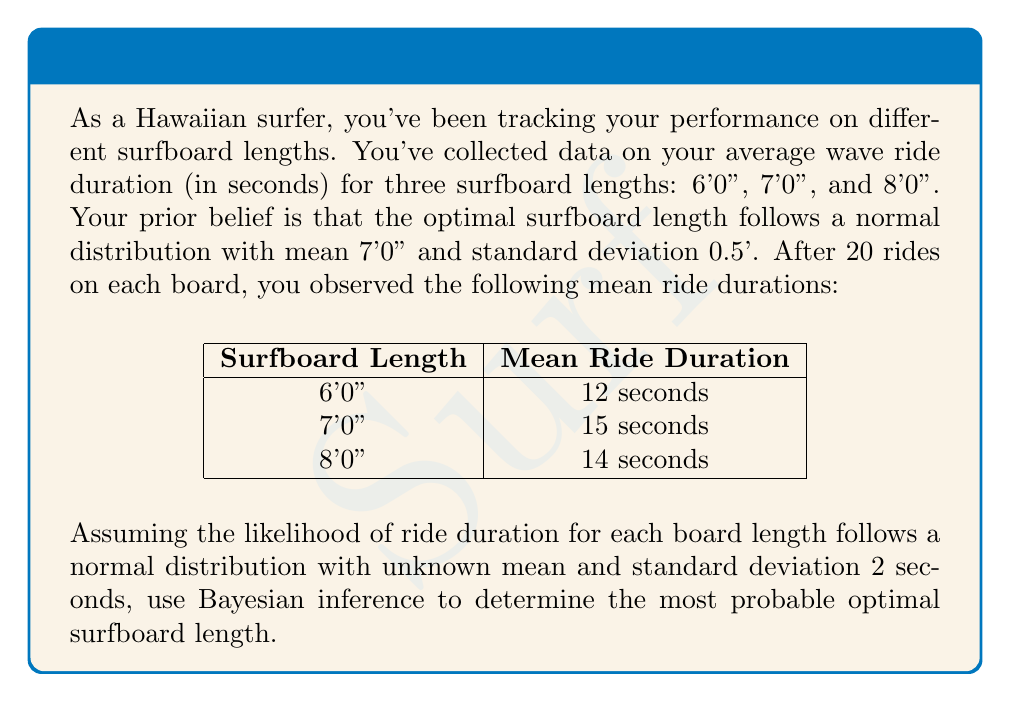Teach me how to tackle this problem. Let's approach this step-by-step using Bayesian inference:

1) Define our variables:
   $\theta$ = optimal surfboard length
   $D$ = observed data

2) We start with a prior distribution:
   $p(\theta) \sim N(7, 0.5^2)$

3) The likelihood function for each board length:
   $p(D|\theta) \sim N(\mu, 2^2)$
   where $\mu$ is the mean ride duration for each length

4) The posterior distribution is proportional to the prior times the likelihood:
   $p(\theta|D) \propto p(\theta) \cdot p(D|\theta)$

5) For each board length, we can calculate a likelihood:
   $L(6') \propto \exp(-\frac{(12-\theta)^2}{2\cdot2^2})$
   $L(7') \propto \exp(-\frac{(15-\theta)^2}{2\cdot2^2})$
   $L(8') \propto \exp(-\frac{(14-\theta)^2}{2\cdot2^2})$

6) The total likelihood is the product of these:
   $L(\theta) \propto L(6') \cdot L(7') \cdot L(8')$

7) The posterior is proportional to:
   $p(\theta|D) \propto \exp(-\frac{(\theta-7)^2}{2\cdot0.5^2}) \cdot \exp(-\frac{(12-\theta)^2+(15-\theta)^2+(14-\theta)^2}{2\cdot2^2})$

8) This is equivalent to a normal distribution. The mean of this distribution will be our most probable optimal length.

9) The mean of the posterior distribution is:

   $$\frac{7/0.5^2 + (12+15+14)/(2^2)}{1/0.5^2 + 3/2^2} \approx 7.21$$

Therefore, the most probable optimal surfboard length is approximately 7'2.5".
Answer: 7'2.5" 